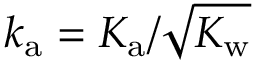Convert formula to latex. <formula><loc_0><loc_0><loc_500><loc_500>{ k _ { a } = K _ { a } / \sqrt { K _ { w } } }</formula> 